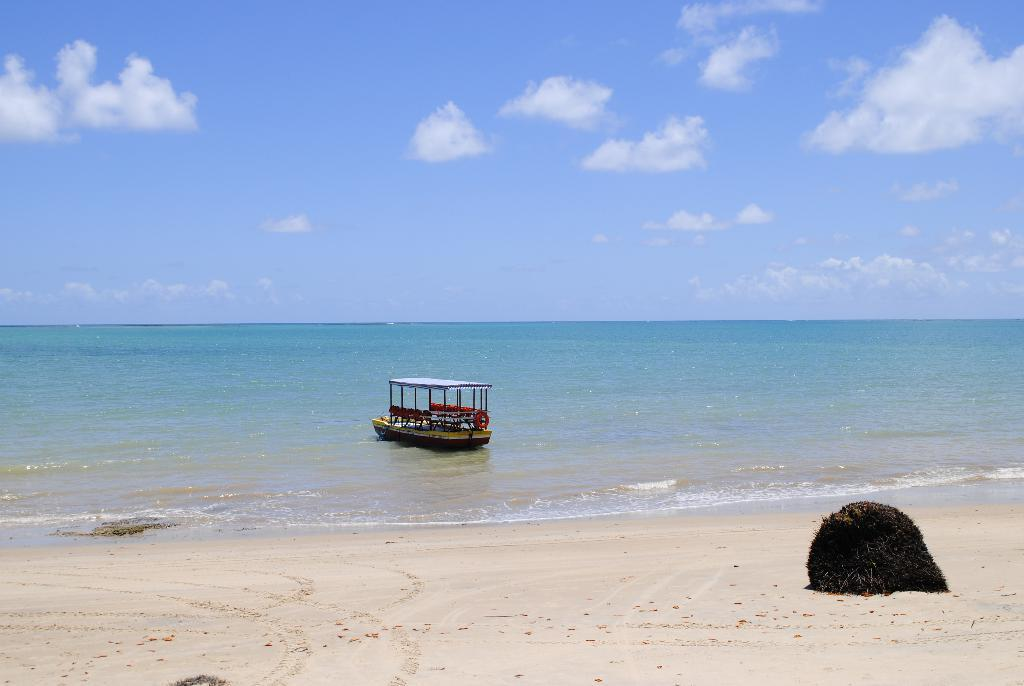What is the black color object on the sand in the image? The factual information provided does not specify the object's identity, so we cannot definitively answer this question. What can be seen in the background of the image? In the background of the image, there is a boat on the water, clouds, and the sky. Where is the boat located in the image? The boat is in the background of the image, on the water. What is the color of the sky in the image? The sky is visible in the background of the image, but the factual information provided does not specify its color. What type of quiver is visible on the sand in the image? There is no quiver present in the image; it features a black color object on the sand, a boat in the background, clouds, and the sky. How many rules are being followed by the clouds in the image? Clouds do not follow rules, and there is no mention of rules in the image. 